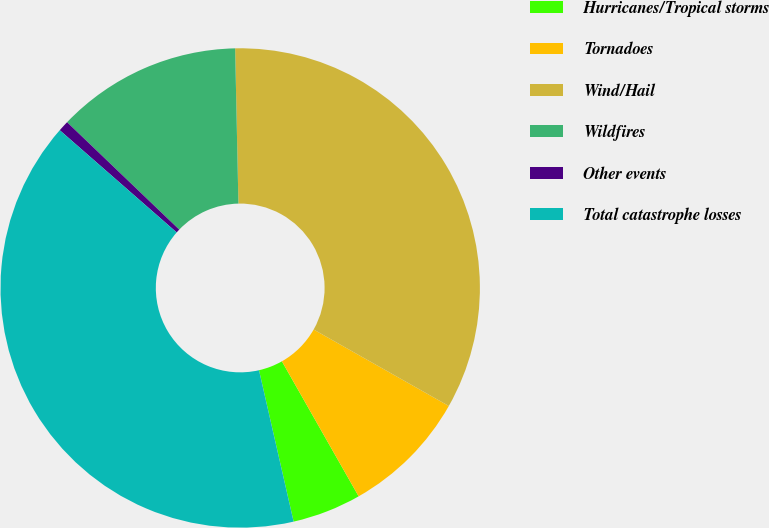<chart> <loc_0><loc_0><loc_500><loc_500><pie_chart><fcel>Hurricanes/Tropical storms<fcel>Tornadoes<fcel>Wind/Hail<fcel>Wildfires<fcel>Other events<fcel>Total catastrophe losses<nl><fcel>4.65%<fcel>8.58%<fcel>33.53%<fcel>12.51%<fcel>0.72%<fcel>40.01%<nl></chart> 